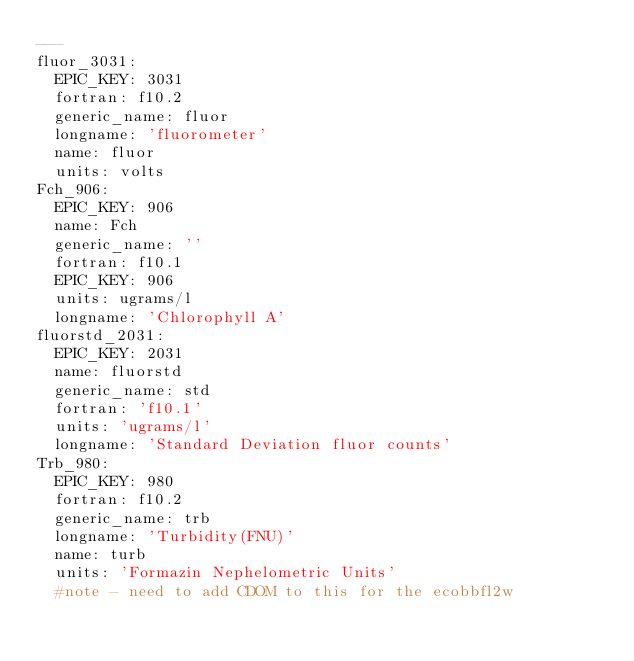<code> <loc_0><loc_0><loc_500><loc_500><_YAML_>---
fluor_3031:
  EPIC_KEY: 3031
  fortran: f10.2
  generic_name: fluor
  longname: 'fluorometer'
  name: fluor
  units: volts
Fch_906: 
  EPIC_KEY: 906
  name: Fch
  generic_name: ''
  fortran: f10.1
  EPIC_KEY: 906
  units: ugrams/l
  longname: 'Chlorophyll A'
fluorstd_2031: 
  EPIC_KEY: 2031
  name: fluorstd
  generic_name: std
  fortran: 'f10.1'
  units: 'ugrams/l'
  longname: 'Standard Deviation fluor counts'
Trb_980:
  EPIC_KEY: 980
  fortran: f10.2
  generic_name: trb
  longname: 'Turbidity(FNU)'
  name: turb
  units: 'Formazin Nephelometric Units'
  #note - need to add CDOM to this for the ecobbfl2w
</code> 